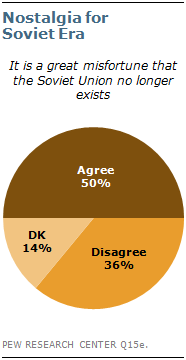List a handful of essential elements in this visual. The DK segment is currently valued at 14%. The sum of the two smallest segments is equal to the largest segment. 